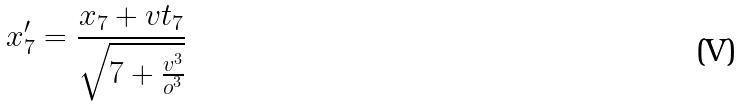Convert formula to latex. <formula><loc_0><loc_0><loc_500><loc_500>x _ { 7 } ^ { \prime } = \frac { x _ { 7 } + v t _ { 7 } } { \sqrt { 7 + \frac { v ^ { 3 } } { o ^ { 3 } } } }</formula> 